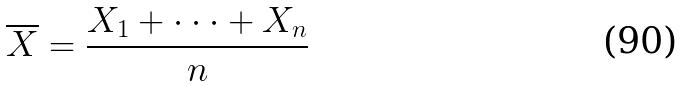<formula> <loc_0><loc_0><loc_500><loc_500>\overline { X } = \frac { X _ { 1 } + \cdot \cdot \cdot + X _ { n } } { n }</formula> 